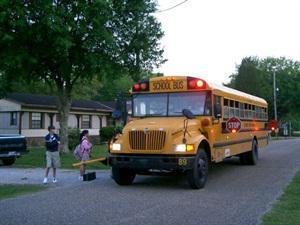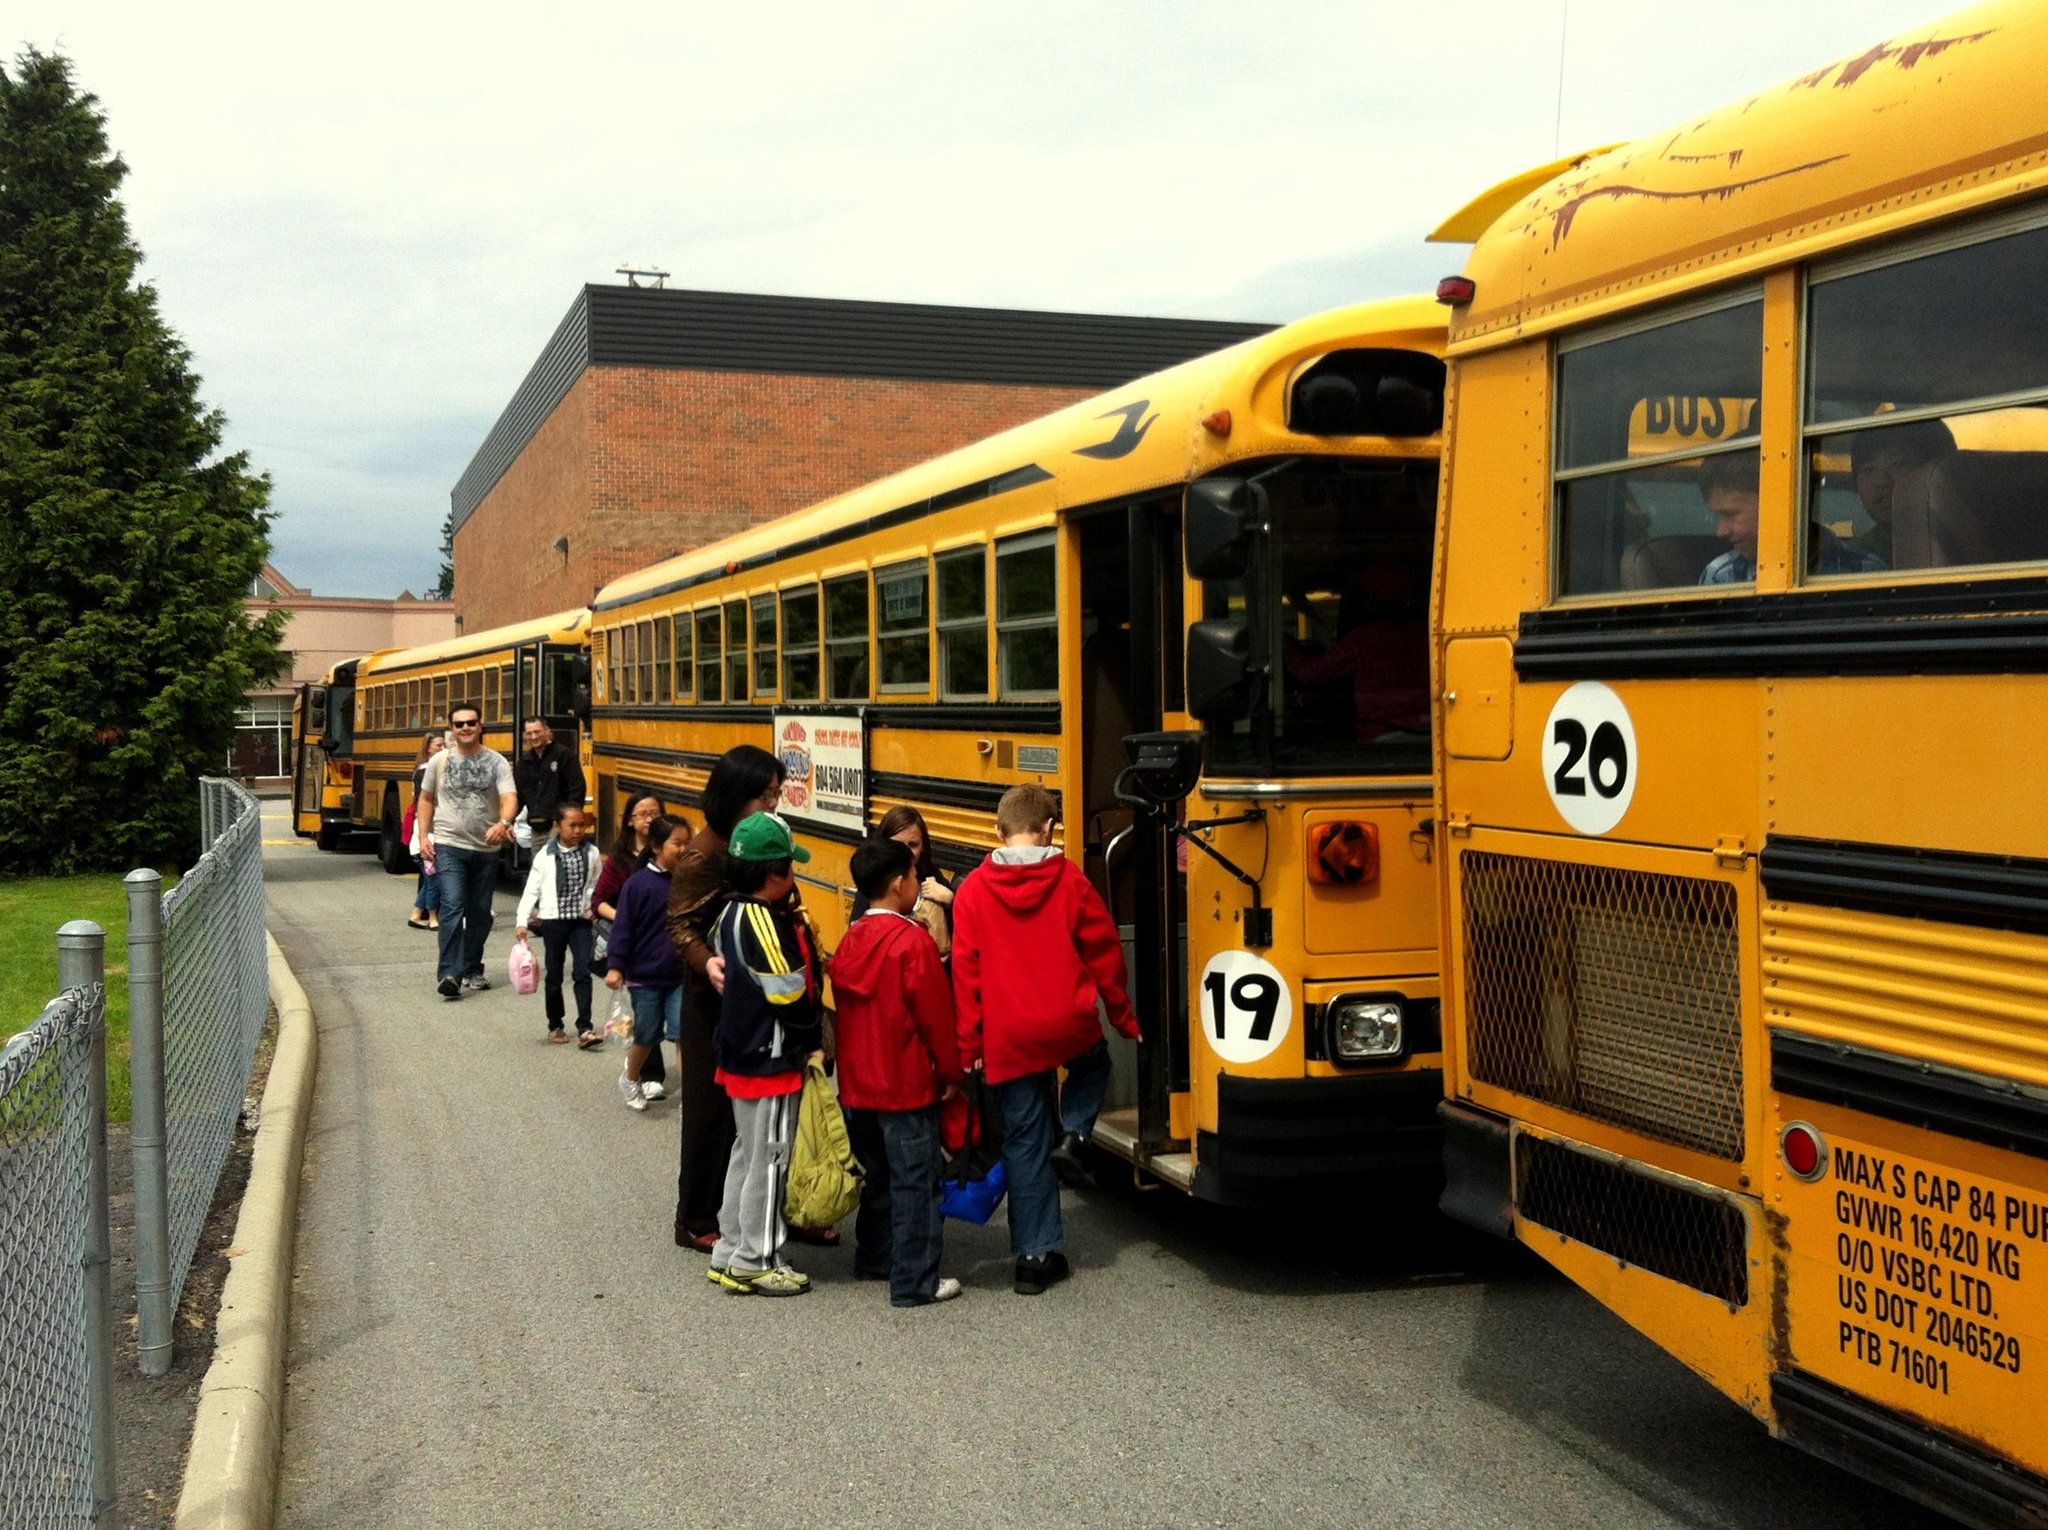The first image is the image on the left, the second image is the image on the right. Examine the images to the left and right. Is the description "A child is entering the open door of a school bus parked at a rightward angle in one image, and the other image shows a leftward angled bus." accurate? Answer yes or no. Yes. The first image is the image on the left, the second image is the image on the right. Analyze the images presented: Is the assertion "People are getting on the bus." valid? Answer yes or no. Yes. 